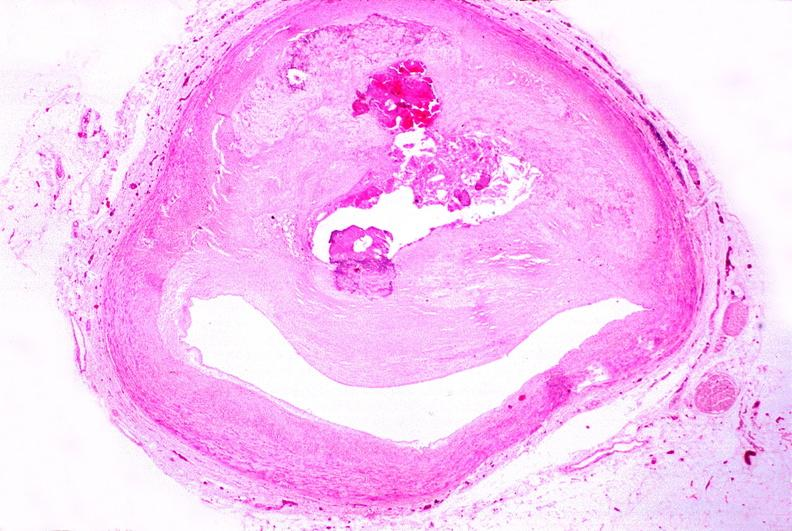s vasculature present?
Answer the question using a single word or phrase. Yes 